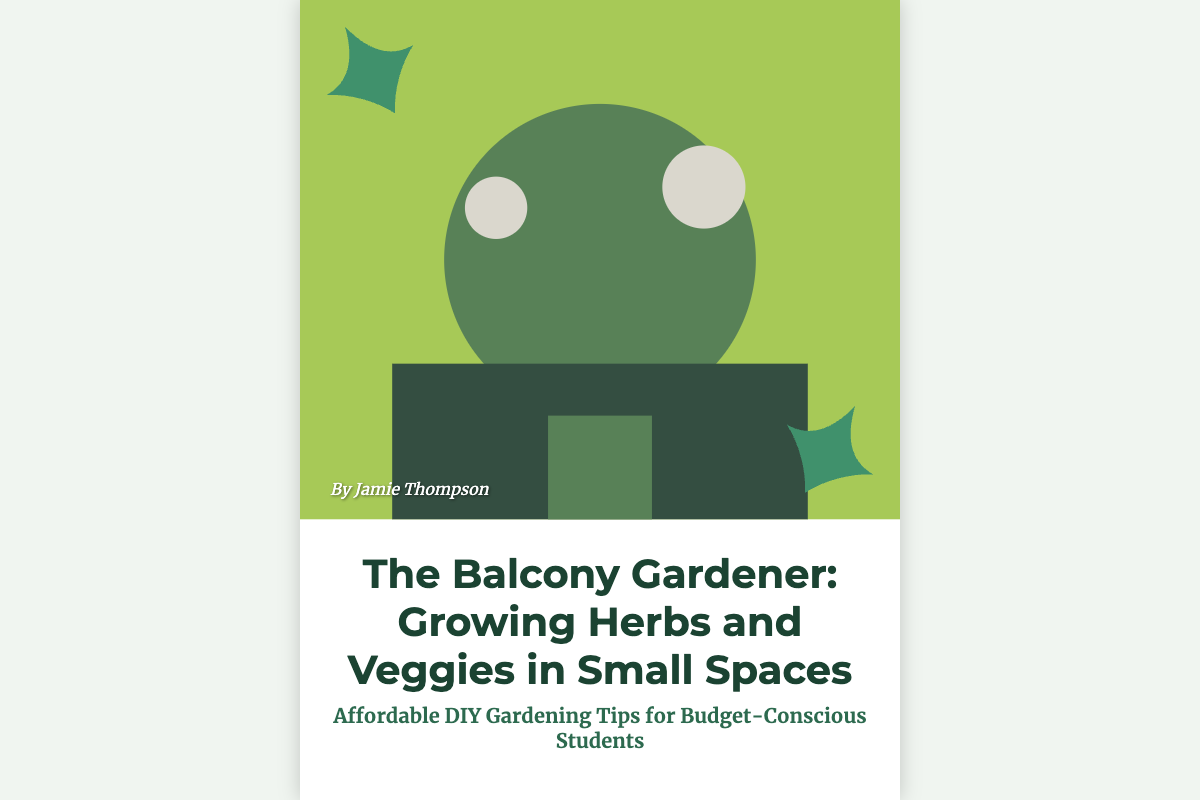What is the title of the book? The title of the book is prominently displayed at the top of the cover.
Answer: The Balcony Gardener: Growing Herbs and Veggies in Small Spaces Who is the author of the book? The author's name is mentioned at the bottom of the cover.
Answer: Jamie Thompson What type of gardening does the book focus on? The subtitle specifies the type of gardening emphasized in the book.
Answer: Herbs and Veggies What is the book's target audience? The subtitle indicates that the book is intended for a specific group.
Answer: Budget-Conscious Students What color primarily fills the background of the cover? The background color of the book cover is visible throughout the design.
Answer: White How many plant decorations are shown on the cover? The count of visual elements representing plants is evident in the design.
Answer: Two What is the main benefit highlighted in the subtitle? The subtitle mentions an important aspect that the book provides for readers.
Answer: Affordable DIY Gardening Tips What does the cover suggest about the space for gardening? The imagery and title suggest a specific limitation for gardening.
Answer: Small Spaces Where are the pots of herbs and vegetables located? The setting indicated by the imagery points to the specific location of gardening.
Answer: On a balcony 